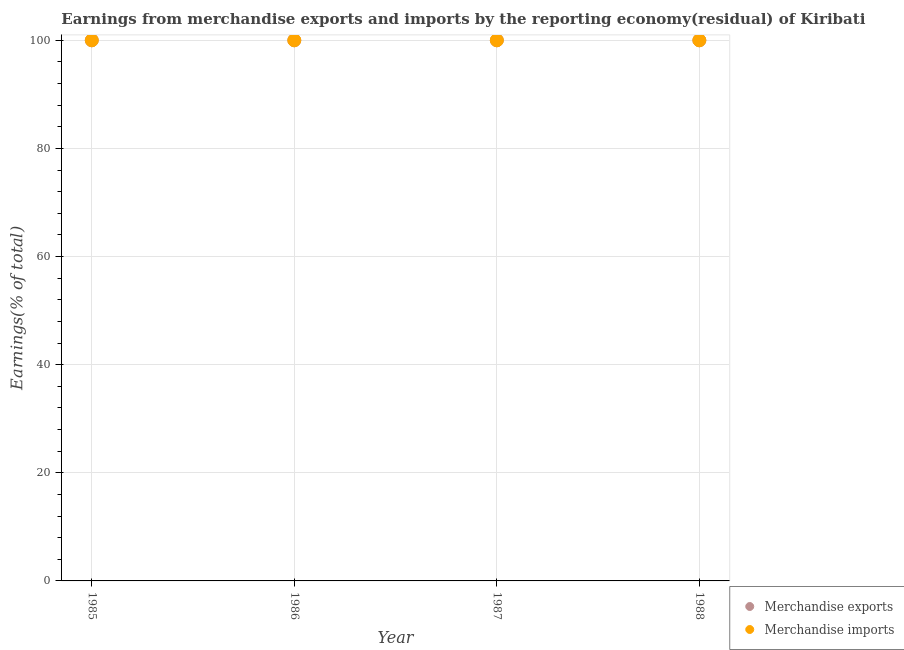Is the number of dotlines equal to the number of legend labels?
Provide a short and direct response. Yes. What is the earnings from merchandise imports in 1988?
Give a very brief answer. 100. Across all years, what is the maximum earnings from merchandise imports?
Give a very brief answer. 100. In which year was the earnings from merchandise exports minimum?
Your answer should be compact. 1985. In how many years, is the earnings from merchandise imports greater than 88 %?
Provide a short and direct response. 4. What is the ratio of the earnings from merchandise exports in 1985 to that in 1986?
Offer a very short reply. 1. Is the difference between the earnings from merchandise imports in 1985 and 1987 greater than the difference between the earnings from merchandise exports in 1985 and 1987?
Provide a short and direct response. No. What is the difference between the highest and the lowest earnings from merchandise exports?
Your answer should be very brief. 0. In how many years, is the earnings from merchandise exports greater than the average earnings from merchandise exports taken over all years?
Your response must be concise. 0. How many years are there in the graph?
Provide a succinct answer. 4. Does the graph contain any zero values?
Offer a very short reply. No. Does the graph contain grids?
Offer a very short reply. Yes. What is the title of the graph?
Make the answer very short. Earnings from merchandise exports and imports by the reporting economy(residual) of Kiribati. What is the label or title of the X-axis?
Your response must be concise. Year. What is the label or title of the Y-axis?
Your answer should be very brief. Earnings(% of total). What is the Earnings(% of total) of Merchandise exports in 1985?
Offer a terse response. 100. What is the Earnings(% of total) in Merchandise exports in 1986?
Keep it short and to the point. 100. What is the Earnings(% of total) in Merchandise imports in 1986?
Your response must be concise. 100. What is the Earnings(% of total) in Merchandise exports in 1987?
Your answer should be compact. 100. What is the Earnings(% of total) of Merchandise exports in 1988?
Give a very brief answer. 100. Across all years, what is the maximum Earnings(% of total) in Merchandise exports?
Your answer should be very brief. 100. Across all years, what is the maximum Earnings(% of total) in Merchandise imports?
Give a very brief answer. 100. Across all years, what is the minimum Earnings(% of total) of Merchandise exports?
Offer a very short reply. 100. Across all years, what is the minimum Earnings(% of total) of Merchandise imports?
Make the answer very short. 100. What is the difference between the Earnings(% of total) in Merchandise exports in 1985 and that in 1987?
Offer a terse response. 0. What is the difference between the Earnings(% of total) of Merchandise imports in 1985 and that in 1988?
Your answer should be very brief. 0. What is the difference between the Earnings(% of total) in Merchandise imports in 1986 and that in 1987?
Ensure brevity in your answer.  0. What is the difference between the Earnings(% of total) of Merchandise exports in 1986 and that in 1988?
Provide a succinct answer. 0. What is the difference between the Earnings(% of total) in Merchandise imports in 1986 and that in 1988?
Your response must be concise. 0. What is the difference between the Earnings(% of total) in Merchandise exports in 1987 and that in 1988?
Give a very brief answer. 0. What is the difference between the Earnings(% of total) in Merchandise exports in 1985 and the Earnings(% of total) in Merchandise imports in 1986?
Make the answer very short. 0. What is the difference between the Earnings(% of total) in Merchandise exports in 1986 and the Earnings(% of total) in Merchandise imports in 1987?
Your answer should be very brief. 0. What is the difference between the Earnings(% of total) of Merchandise exports in 1987 and the Earnings(% of total) of Merchandise imports in 1988?
Your answer should be very brief. 0. What is the average Earnings(% of total) of Merchandise exports per year?
Provide a succinct answer. 100. What is the average Earnings(% of total) of Merchandise imports per year?
Make the answer very short. 100. In the year 1987, what is the difference between the Earnings(% of total) in Merchandise exports and Earnings(% of total) in Merchandise imports?
Offer a very short reply. 0. What is the ratio of the Earnings(% of total) in Merchandise exports in 1985 to that in 1986?
Make the answer very short. 1. What is the ratio of the Earnings(% of total) of Merchandise imports in 1985 to that in 1986?
Your answer should be very brief. 1. What is the ratio of the Earnings(% of total) in Merchandise imports in 1985 to that in 1987?
Make the answer very short. 1. What is the ratio of the Earnings(% of total) of Merchandise exports in 1985 to that in 1988?
Your answer should be compact. 1. What is the difference between the highest and the lowest Earnings(% of total) of Merchandise exports?
Keep it short and to the point. 0. 